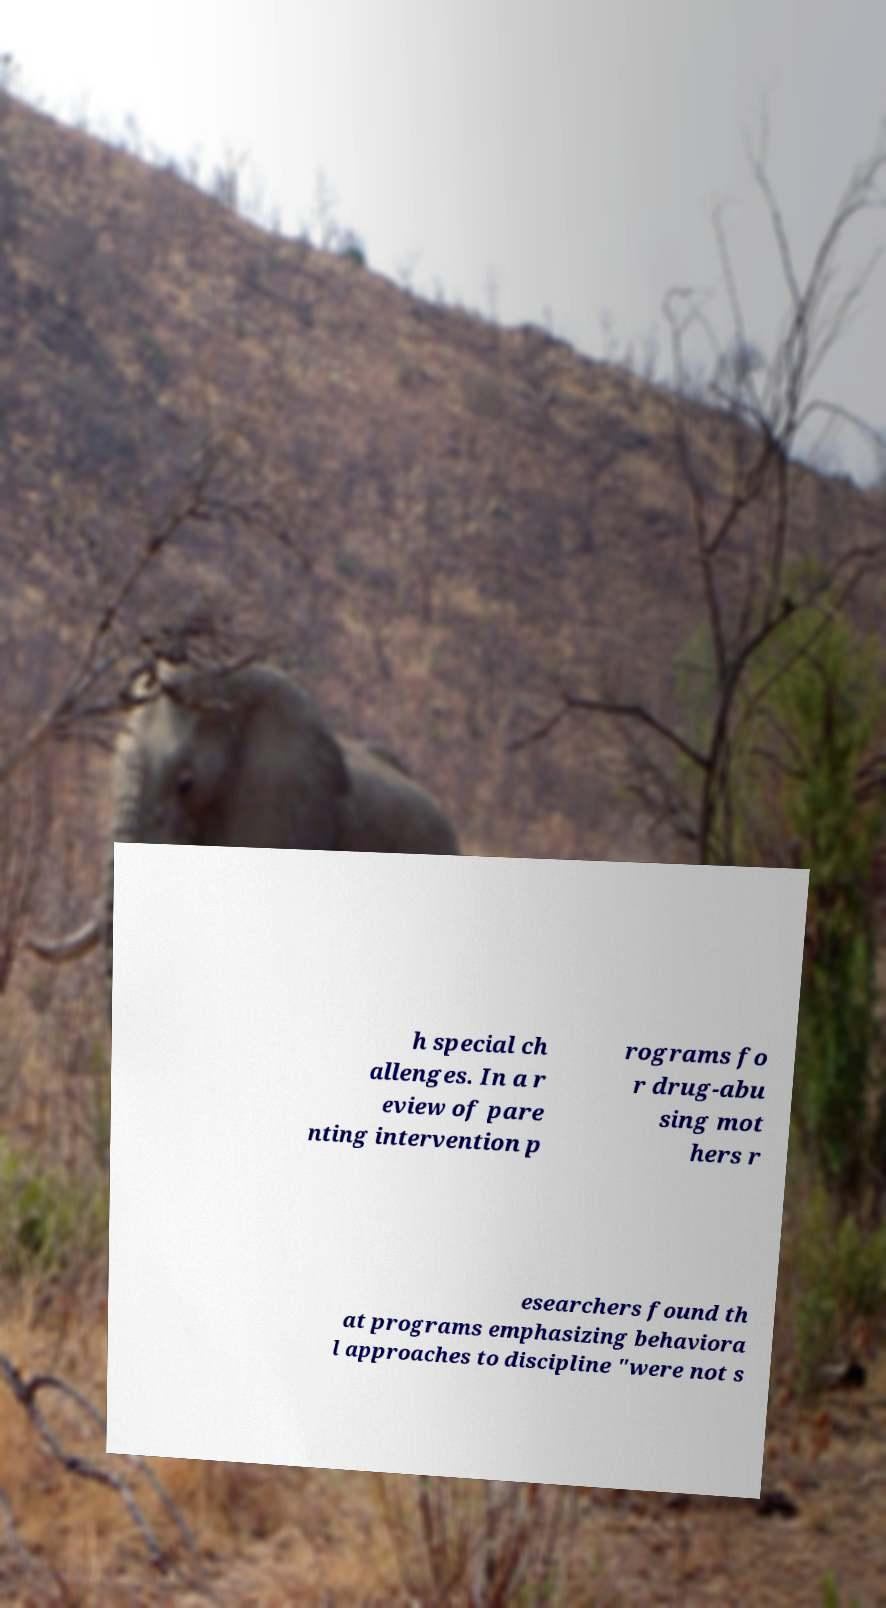For documentation purposes, I need the text within this image transcribed. Could you provide that? h special ch allenges. In a r eview of pare nting intervention p rograms fo r drug-abu sing mot hers r esearchers found th at programs emphasizing behaviora l approaches to discipline "were not s 